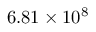Convert formula to latex. <formula><loc_0><loc_0><loc_500><loc_500>6 . 8 1 \times 1 0 ^ { 8 }</formula> 